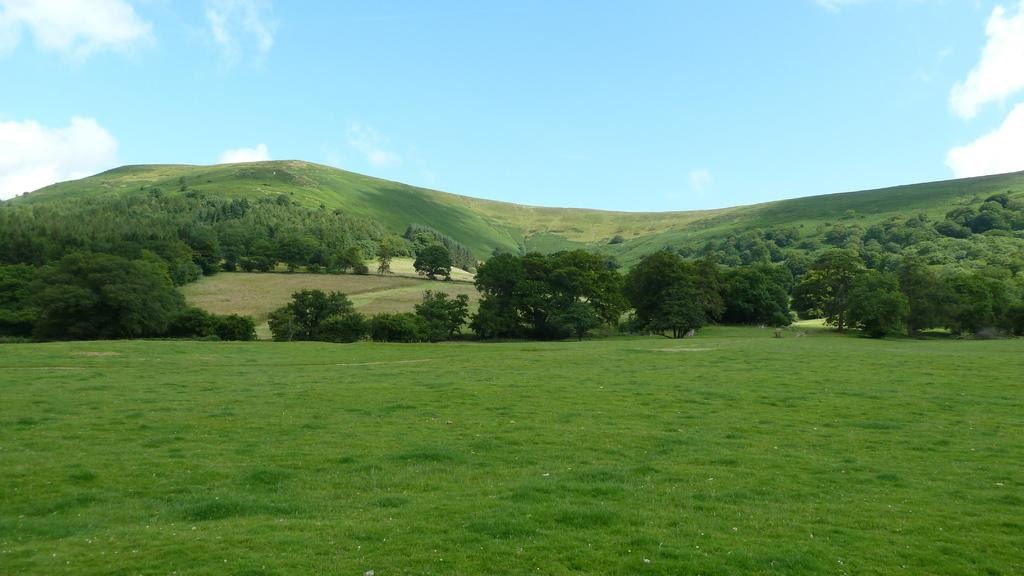What type of ground surface is visible in the image? There is grass on the ground in the image. How are the trees arranged in the image? The trees are arranged from left to right in the image. What can be seen in the background of the image? There is greenery in the background of the image. How would you describe the sky in the image? The sky is blue and cloudy in the image. Where is the crate of produce located in the image? There is no crate of produce present in the image. What type of airport can be seen in the image? There is no airport present in the image. 